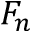<formula> <loc_0><loc_0><loc_500><loc_500>F _ { n }</formula> 